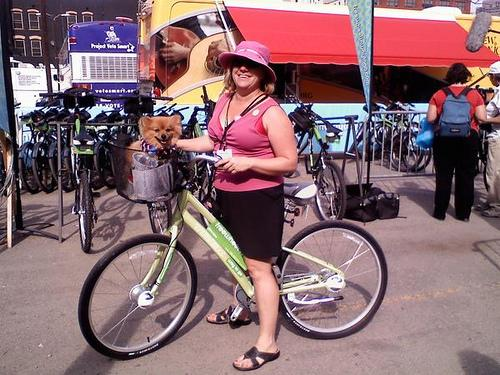What kind of accessory should the woman wear? helmet 